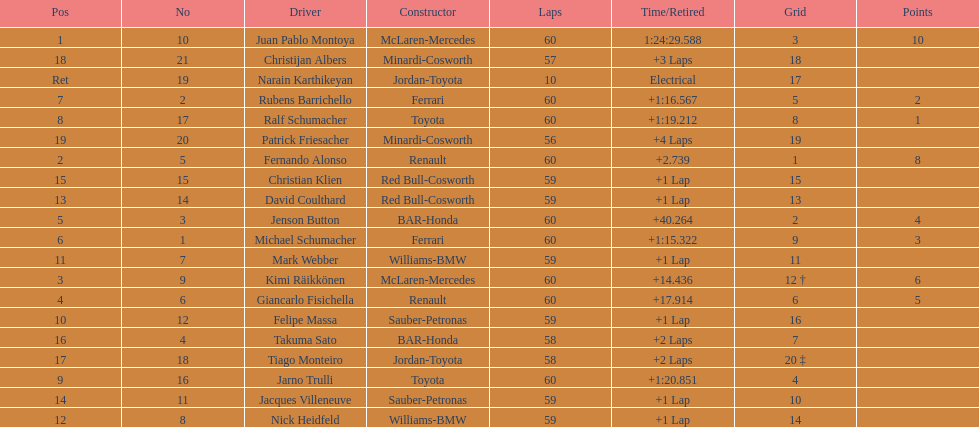How many drivers from germany? 3. 